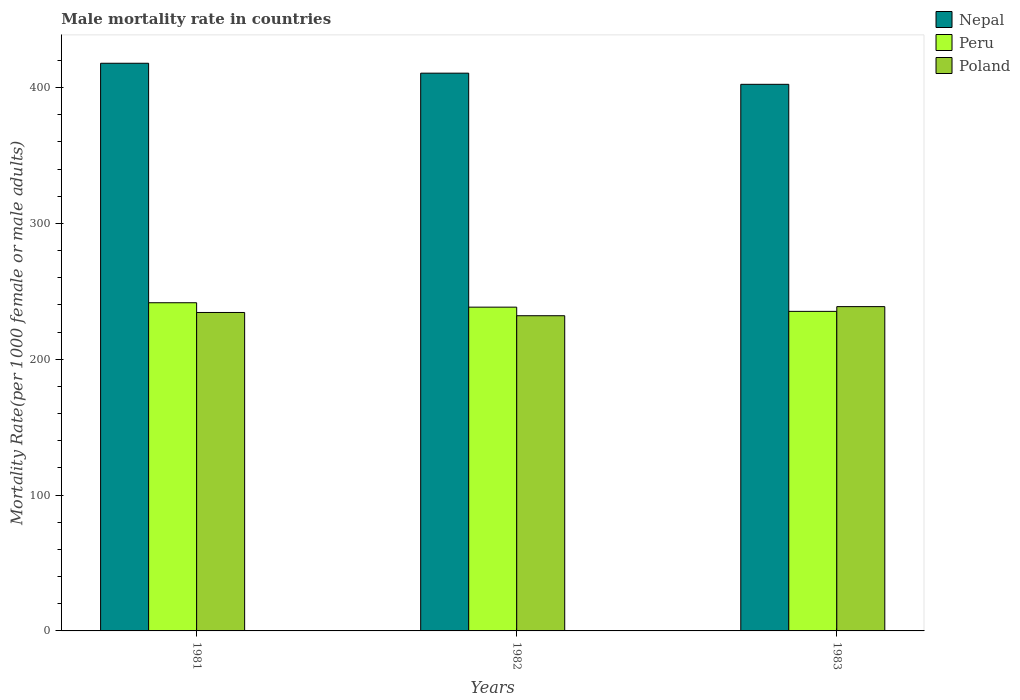Are the number of bars on each tick of the X-axis equal?
Ensure brevity in your answer.  Yes. What is the label of the 1st group of bars from the left?
Offer a terse response. 1981. In how many cases, is the number of bars for a given year not equal to the number of legend labels?
Your response must be concise. 0. What is the male mortality rate in Peru in 1981?
Your answer should be compact. 241.57. Across all years, what is the maximum male mortality rate in Poland?
Offer a very short reply. 238.72. Across all years, what is the minimum male mortality rate in Nepal?
Your answer should be very brief. 402.35. What is the total male mortality rate in Poland in the graph?
Keep it short and to the point. 705.15. What is the difference between the male mortality rate in Poland in 1981 and that in 1982?
Your answer should be very brief. 2.39. What is the difference between the male mortality rate in Nepal in 1981 and the male mortality rate in Poland in 1983?
Your response must be concise. 179.13. What is the average male mortality rate in Nepal per year?
Your response must be concise. 410.26. In the year 1981, what is the difference between the male mortality rate in Nepal and male mortality rate in Peru?
Offer a very short reply. 176.28. What is the ratio of the male mortality rate in Poland in 1981 to that in 1983?
Ensure brevity in your answer.  0.98. Is the male mortality rate in Peru in 1981 less than that in 1983?
Your response must be concise. No. Is the difference between the male mortality rate in Nepal in 1982 and 1983 greater than the difference between the male mortality rate in Peru in 1982 and 1983?
Your response must be concise. Yes. What is the difference between the highest and the second highest male mortality rate in Poland?
Provide a short and direct response. 4.32. What is the difference between the highest and the lowest male mortality rate in Poland?
Your answer should be compact. 6.71. In how many years, is the male mortality rate in Poland greater than the average male mortality rate in Poland taken over all years?
Provide a succinct answer. 1. What does the 3rd bar from the right in 1983 represents?
Provide a short and direct response. Nepal. Is it the case that in every year, the sum of the male mortality rate in Nepal and male mortality rate in Poland is greater than the male mortality rate in Peru?
Keep it short and to the point. Yes. How many bars are there?
Offer a terse response. 9. What is the difference between two consecutive major ticks on the Y-axis?
Make the answer very short. 100. Does the graph contain any zero values?
Offer a very short reply. No. Does the graph contain grids?
Make the answer very short. No. How are the legend labels stacked?
Your answer should be very brief. Vertical. What is the title of the graph?
Ensure brevity in your answer.  Male mortality rate in countries. Does "Palau" appear as one of the legend labels in the graph?
Make the answer very short. No. What is the label or title of the Y-axis?
Your answer should be compact. Mortality Rate(per 1000 female or male adults). What is the Mortality Rate(per 1000 female or male adults) of Nepal in 1981?
Offer a very short reply. 417.86. What is the Mortality Rate(per 1000 female or male adults) in Peru in 1981?
Offer a terse response. 241.57. What is the Mortality Rate(per 1000 female or male adults) in Poland in 1981?
Your answer should be very brief. 234.41. What is the Mortality Rate(per 1000 female or male adults) in Nepal in 1982?
Ensure brevity in your answer.  410.57. What is the Mortality Rate(per 1000 female or male adults) in Peru in 1982?
Offer a terse response. 238.32. What is the Mortality Rate(per 1000 female or male adults) of Poland in 1982?
Give a very brief answer. 232.02. What is the Mortality Rate(per 1000 female or male adults) of Nepal in 1983?
Your response must be concise. 402.35. What is the Mortality Rate(per 1000 female or male adults) in Peru in 1983?
Make the answer very short. 235.22. What is the Mortality Rate(per 1000 female or male adults) in Poland in 1983?
Your answer should be very brief. 238.72. Across all years, what is the maximum Mortality Rate(per 1000 female or male adults) of Nepal?
Your response must be concise. 417.86. Across all years, what is the maximum Mortality Rate(per 1000 female or male adults) of Peru?
Offer a very short reply. 241.57. Across all years, what is the maximum Mortality Rate(per 1000 female or male adults) of Poland?
Your answer should be very brief. 238.72. Across all years, what is the minimum Mortality Rate(per 1000 female or male adults) of Nepal?
Offer a very short reply. 402.35. Across all years, what is the minimum Mortality Rate(per 1000 female or male adults) in Peru?
Offer a very short reply. 235.22. Across all years, what is the minimum Mortality Rate(per 1000 female or male adults) in Poland?
Give a very brief answer. 232.02. What is the total Mortality Rate(per 1000 female or male adults) of Nepal in the graph?
Ensure brevity in your answer.  1230.78. What is the total Mortality Rate(per 1000 female or male adults) of Peru in the graph?
Keep it short and to the point. 715.12. What is the total Mortality Rate(per 1000 female or male adults) in Poland in the graph?
Give a very brief answer. 705.15. What is the difference between the Mortality Rate(per 1000 female or male adults) in Nepal in 1981 and that in 1982?
Keep it short and to the point. 7.29. What is the difference between the Mortality Rate(per 1000 female or male adults) of Poland in 1981 and that in 1982?
Make the answer very short. 2.39. What is the difference between the Mortality Rate(per 1000 female or male adults) of Nepal in 1981 and that in 1983?
Your response must be concise. 15.51. What is the difference between the Mortality Rate(per 1000 female or male adults) of Peru in 1981 and that in 1983?
Ensure brevity in your answer.  6.35. What is the difference between the Mortality Rate(per 1000 female or male adults) in Poland in 1981 and that in 1983?
Ensure brevity in your answer.  -4.32. What is the difference between the Mortality Rate(per 1000 female or male adults) in Nepal in 1982 and that in 1983?
Your response must be concise. 8.22. What is the difference between the Mortality Rate(per 1000 female or male adults) of Peru in 1982 and that in 1983?
Provide a succinct answer. 3.1. What is the difference between the Mortality Rate(per 1000 female or male adults) in Poland in 1982 and that in 1983?
Keep it short and to the point. -6.71. What is the difference between the Mortality Rate(per 1000 female or male adults) in Nepal in 1981 and the Mortality Rate(per 1000 female or male adults) in Peru in 1982?
Your answer should be very brief. 179.53. What is the difference between the Mortality Rate(per 1000 female or male adults) in Nepal in 1981 and the Mortality Rate(per 1000 female or male adults) in Poland in 1982?
Give a very brief answer. 185.84. What is the difference between the Mortality Rate(per 1000 female or male adults) in Peru in 1981 and the Mortality Rate(per 1000 female or male adults) in Poland in 1982?
Give a very brief answer. 9.56. What is the difference between the Mortality Rate(per 1000 female or male adults) of Nepal in 1981 and the Mortality Rate(per 1000 female or male adults) of Peru in 1983?
Make the answer very short. 182.64. What is the difference between the Mortality Rate(per 1000 female or male adults) of Nepal in 1981 and the Mortality Rate(per 1000 female or male adults) of Poland in 1983?
Ensure brevity in your answer.  179.13. What is the difference between the Mortality Rate(per 1000 female or male adults) in Peru in 1981 and the Mortality Rate(per 1000 female or male adults) in Poland in 1983?
Your response must be concise. 2.85. What is the difference between the Mortality Rate(per 1000 female or male adults) in Nepal in 1982 and the Mortality Rate(per 1000 female or male adults) in Peru in 1983?
Keep it short and to the point. 175.35. What is the difference between the Mortality Rate(per 1000 female or male adults) in Nepal in 1982 and the Mortality Rate(per 1000 female or male adults) in Poland in 1983?
Your answer should be very brief. 171.84. What is the difference between the Mortality Rate(per 1000 female or male adults) in Peru in 1982 and the Mortality Rate(per 1000 female or male adults) in Poland in 1983?
Keep it short and to the point. -0.4. What is the average Mortality Rate(per 1000 female or male adults) of Nepal per year?
Provide a succinct answer. 410.26. What is the average Mortality Rate(per 1000 female or male adults) of Peru per year?
Ensure brevity in your answer.  238.37. What is the average Mortality Rate(per 1000 female or male adults) of Poland per year?
Your answer should be very brief. 235.05. In the year 1981, what is the difference between the Mortality Rate(per 1000 female or male adults) of Nepal and Mortality Rate(per 1000 female or male adults) of Peru?
Your answer should be compact. 176.28. In the year 1981, what is the difference between the Mortality Rate(per 1000 female or male adults) in Nepal and Mortality Rate(per 1000 female or male adults) in Poland?
Give a very brief answer. 183.45. In the year 1981, what is the difference between the Mortality Rate(per 1000 female or male adults) in Peru and Mortality Rate(per 1000 female or male adults) in Poland?
Keep it short and to the point. 7.17. In the year 1982, what is the difference between the Mortality Rate(per 1000 female or male adults) in Nepal and Mortality Rate(per 1000 female or male adults) in Peru?
Ensure brevity in your answer.  172.25. In the year 1982, what is the difference between the Mortality Rate(per 1000 female or male adults) of Nepal and Mortality Rate(per 1000 female or male adults) of Poland?
Provide a succinct answer. 178.55. In the year 1982, what is the difference between the Mortality Rate(per 1000 female or male adults) in Peru and Mortality Rate(per 1000 female or male adults) in Poland?
Offer a very short reply. 6.31. In the year 1983, what is the difference between the Mortality Rate(per 1000 female or male adults) of Nepal and Mortality Rate(per 1000 female or male adults) of Peru?
Make the answer very short. 167.13. In the year 1983, what is the difference between the Mortality Rate(per 1000 female or male adults) in Nepal and Mortality Rate(per 1000 female or male adults) in Poland?
Ensure brevity in your answer.  163.62. In the year 1983, what is the difference between the Mortality Rate(per 1000 female or male adults) in Peru and Mortality Rate(per 1000 female or male adults) in Poland?
Offer a very short reply. -3.51. What is the ratio of the Mortality Rate(per 1000 female or male adults) of Nepal in 1981 to that in 1982?
Offer a very short reply. 1.02. What is the ratio of the Mortality Rate(per 1000 female or male adults) of Peru in 1981 to that in 1982?
Your answer should be very brief. 1.01. What is the ratio of the Mortality Rate(per 1000 female or male adults) in Poland in 1981 to that in 1982?
Give a very brief answer. 1.01. What is the ratio of the Mortality Rate(per 1000 female or male adults) in Nepal in 1981 to that in 1983?
Make the answer very short. 1.04. What is the ratio of the Mortality Rate(per 1000 female or male adults) of Poland in 1981 to that in 1983?
Provide a short and direct response. 0.98. What is the ratio of the Mortality Rate(per 1000 female or male adults) in Nepal in 1982 to that in 1983?
Keep it short and to the point. 1.02. What is the ratio of the Mortality Rate(per 1000 female or male adults) in Peru in 1982 to that in 1983?
Make the answer very short. 1.01. What is the ratio of the Mortality Rate(per 1000 female or male adults) of Poland in 1982 to that in 1983?
Offer a terse response. 0.97. What is the difference between the highest and the second highest Mortality Rate(per 1000 female or male adults) of Nepal?
Your answer should be compact. 7.29. What is the difference between the highest and the second highest Mortality Rate(per 1000 female or male adults) of Peru?
Ensure brevity in your answer.  3.25. What is the difference between the highest and the second highest Mortality Rate(per 1000 female or male adults) of Poland?
Make the answer very short. 4.32. What is the difference between the highest and the lowest Mortality Rate(per 1000 female or male adults) in Nepal?
Ensure brevity in your answer.  15.51. What is the difference between the highest and the lowest Mortality Rate(per 1000 female or male adults) in Peru?
Keep it short and to the point. 6.35. What is the difference between the highest and the lowest Mortality Rate(per 1000 female or male adults) of Poland?
Offer a very short reply. 6.71. 